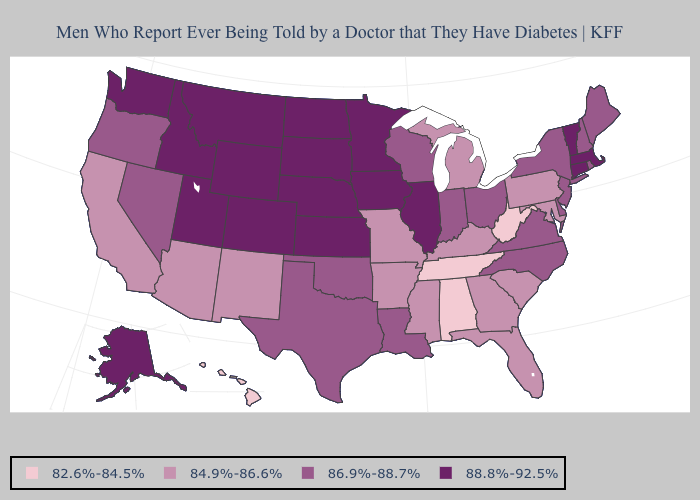Does New York have the lowest value in the USA?
Concise answer only. No. Does the map have missing data?
Answer briefly. No. What is the lowest value in the USA?
Be succinct. 82.6%-84.5%. Does Missouri have the lowest value in the MidWest?
Be succinct. Yes. What is the lowest value in the South?
Write a very short answer. 82.6%-84.5%. Which states have the lowest value in the USA?
Quick response, please. Alabama, Hawaii, Tennessee, West Virginia. Name the states that have a value in the range 88.8%-92.5%?
Give a very brief answer. Alaska, Colorado, Connecticut, Idaho, Illinois, Iowa, Kansas, Massachusetts, Minnesota, Montana, Nebraska, North Dakota, South Dakota, Utah, Vermont, Washington, Wyoming. Name the states that have a value in the range 86.9%-88.7%?
Give a very brief answer. Delaware, Indiana, Louisiana, Maine, Nevada, New Hampshire, New Jersey, New York, North Carolina, Ohio, Oklahoma, Oregon, Rhode Island, Texas, Virginia, Wisconsin. What is the value of Illinois?
Keep it brief. 88.8%-92.5%. What is the lowest value in the USA?
Concise answer only. 82.6%-84.5%. Name the states that have a value in the range 86.9%-88.7%?
Be succinct. Delaware, Indiana, Louisiana, Maine, Nevada, New Hampshire, New Jersey, New York, North Carolina, Ohio, Oklahoma, Oregon, Rhode Island, Texas, Virginia, Wisconsin. What is the value of Colorado?
Keep it brief. 88.8%-92.5%. Does Idaho have the highest value in the USA?
Be succinct. Yes. Which states hav the highest value in the South?
Keep it brief. Delaware, Louisiana, North Carolina, Oklahoma, Texas, Virginia. 